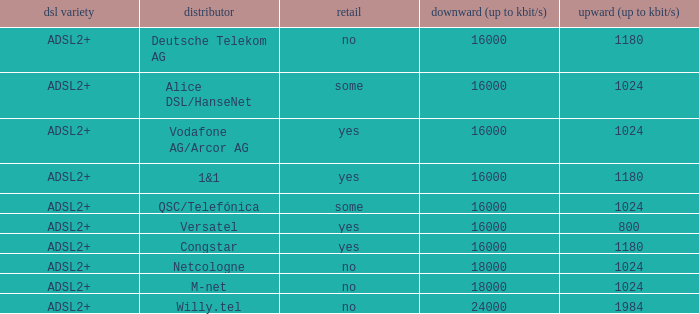What is the resale category for the provider NetCologne? No. 